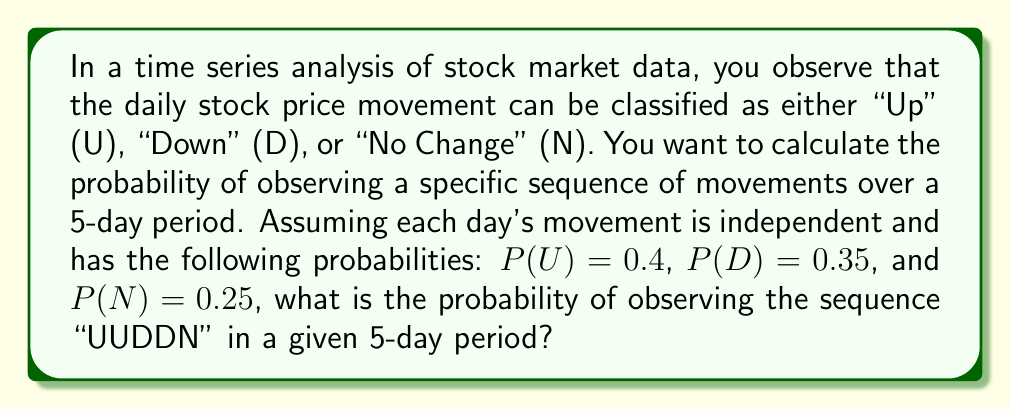Teach me how to tackle this problem. To solve this problem, we need to use the concept of independent events and the multiplication rule of probability. Since each day's movement is independent, we can multiply the probabilities of individual events to find the probability of the entire sequence.

Let's break down the sequence "UUDDN":

1. Day 1: Up (U)
2. Day 2: Up (U)
3. Day 3: Down (D)
4. Day 4: Down (D)
5. Day 5: No Change (N)

Now, let's calculate the probability of each event:

1. P(U) = 0.4
2. P(U) = 0.4
3. P(D) = 0.35
4. P(D) = 0.35
5. P(N) = 0.25

To find the probability of this specific sequence, we multiply these individual probabilities:

$$P(\text{UUDDN}) = P(U) \times P(U) \times P(D) \times P(D) \times P(N)$$

Substituting the values:

$$P(\text{UUDDN}) = 0.4 \times 0.4 \times 0.35 \times 0.35 \times 0.25$$

Calculating:

$$P(\text{UUDDN}) = 0.00245$$

Therefore, the probability of observing the sequence "UUDDN" in a given 5-day period is 0.00245 or 0.245%.
Answer: 0.00245 or 0.245% 